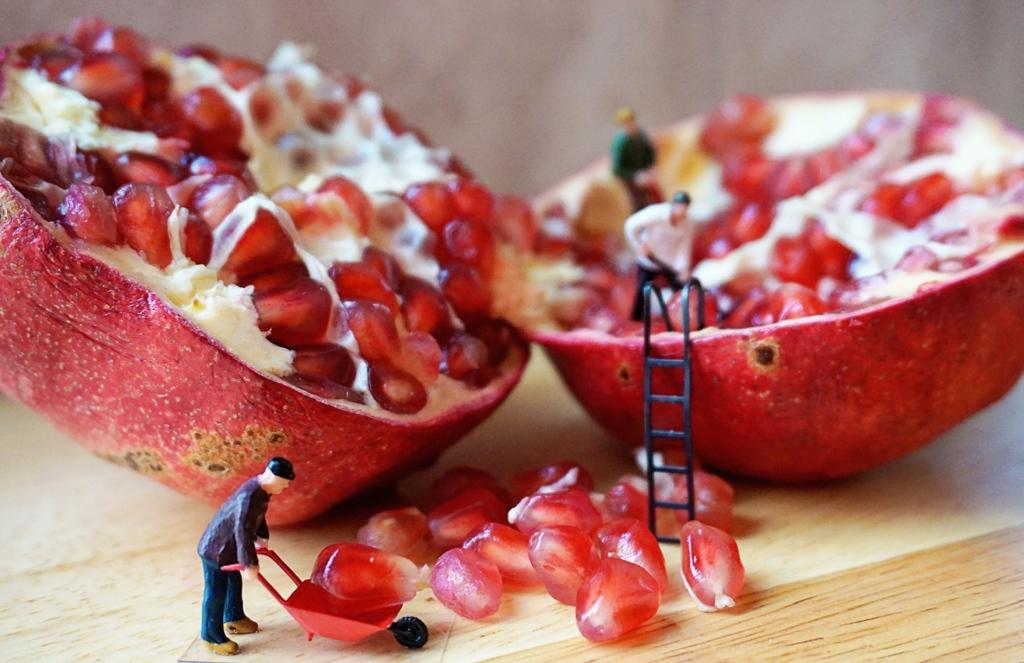What type of furniture is present in the image? There is a table in the image. What is placed on the table? There is a pomegranate on the table. What else can be seen in the image besides the table and pomegranate? There are toys in the image. What type of prose is being recited by the toys in the image? There are no toys reciting prose in the image; they are simply toys. 